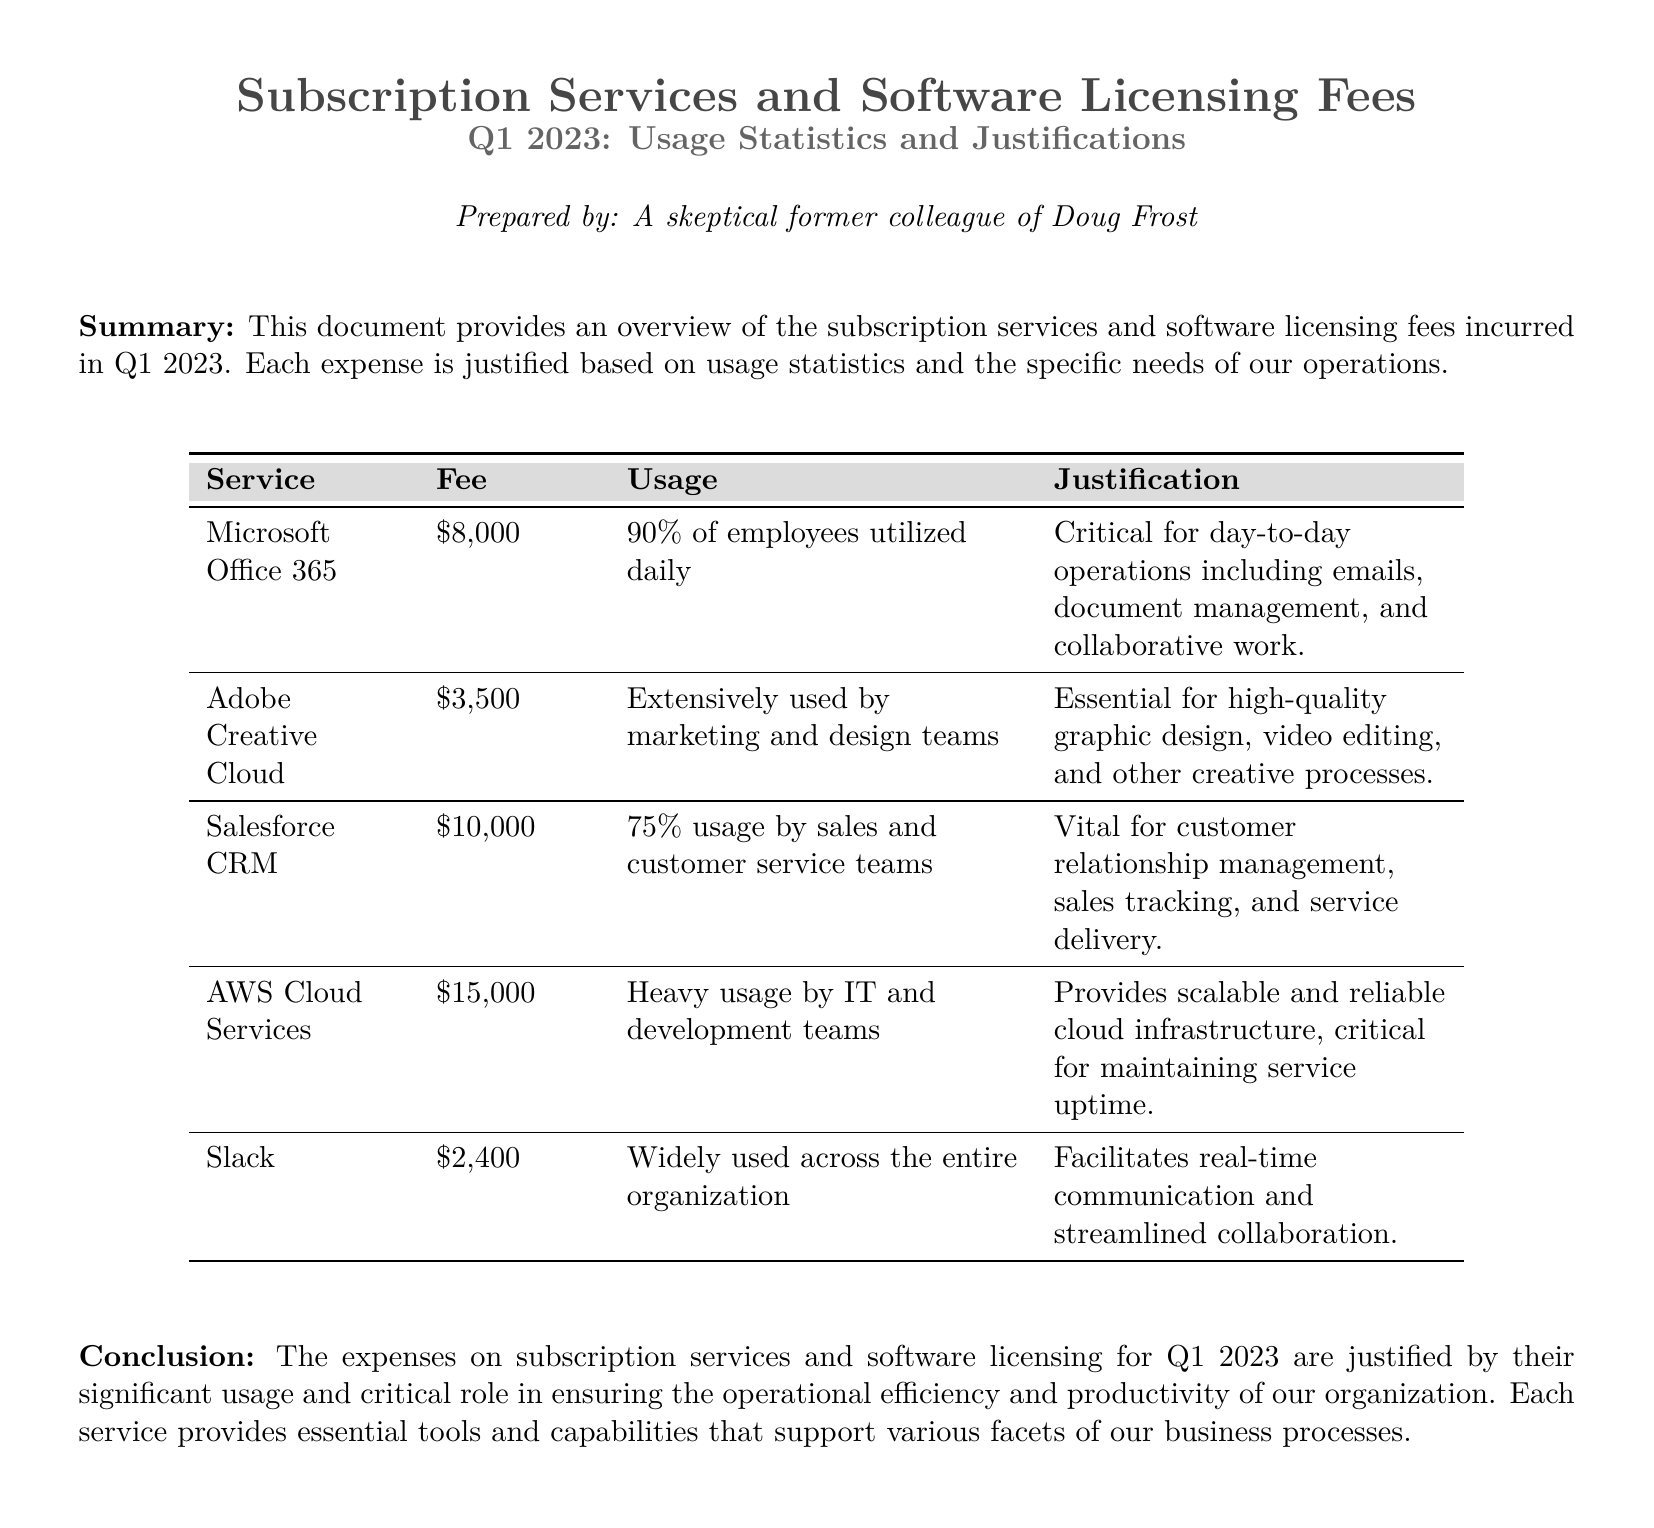What is the total fee for Microsoft Office 365? The fee for Microsoft Office 365 is listed in the table as $8,000.
Answer: $8,000 What percentage of employees utilized Microsoft Office 365 daily? The document states that 90% of employees utilized Microsoft Office 365 daily.
Answer: 90% Which subscription service has the highest fee? The table indicates that AWS Cloud Services has the highest fee at $15,000.
Answer: AWS Cloud Services How much did the company spend on Adobe Creative Cloud? The cost reported for Adobe Creative Cloud is $3,500.
Answer: $3,500 What is the usage percentage of Salesforce CRM by the sales and customer service teams? The document mentions that 75% usage of Salesforce CRM is by these teams.
Answer: 75% Why is Microsoft Office 365 considered a critical service? Microsoft Office 365 is justified as critical for day-to-day operations including emails, document management, and collaborative work.
Answer: Emails, document management, collaborative work How much did the organization spend on Slack? The expense for Slack is stated as $2,400 in the document.
Answer: $2,400 What is the total expenditure of the subscription services listed? The total expenditure is calculated as $8,000 + $3,500 + $10,000 + $15,000 + $2,400 = $38,900.
Answer: $38,900 What type of usage is noted for AWS Cloud Services? Heavy usage by IT and development teams is noted for AWS Cloud Services.
Answer: Heavy usage 